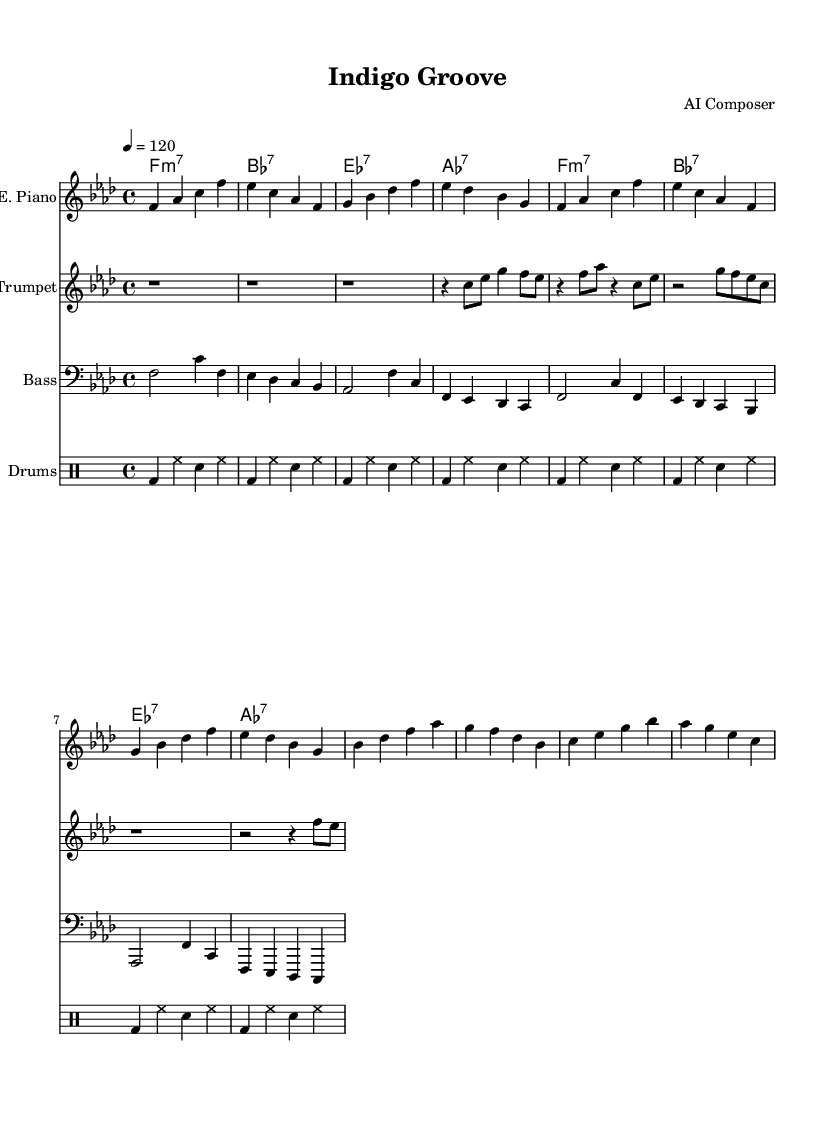What is the key signature of this music? The key signature in the sheet music is indicated by the F minor scale, which has four flats: B♭, E♭, A♭, and D♭. This can be seen in the key signature section found at the beginning of the sheet music.
Answer: F minor What is the time signature of this piece? The time signature is shown at the beginning of the score as 4/4, meaning there are four beats in a measure and the quarter note gets one beat. This information is typically located right next to the key signature in the sheet music.
Answer: 4/4 What is the tempo marking for this music? The tempo marking of the piece is indicated as 4 = 120. This means that the quarter note (4) should be played at a speed of 120 beats per minute, which is located at the beginning of the score.
Answer: 120 How many measures are included in the electric piano part? By counting the number of bar lines (vertical lines) in the electric piano part, we find that there are 8 measures total. Each bar line denotes the end of a measure, and careful counting reveals the total.
Answer: 8 What is the dominant chord used in the chorus? The dominant chord (the fifth chord) of the key of F minor is C major or C7, which is represented in the chord names section of the sheet music. Chord names typically indicate harmonic progressions and help identify key chords.
Answer: C7 How many different instruments are featured in this piece? From the score layout, we can observe that there are four different staves for instruments: Electric Piano, Trumpet, Bass, and Drums. Each staff corresponds to a separate instrument part being played.
Answer: Four What rhythmic element is prominently featured in the drum part? The drum part prominently features a bass drum (bd) on the first beat of each measure, followed by hi-hat (hh) and snare (sn) patterns. The pattern of bass, hi-hat, and snare creates a distinct rhythmic groove, which is identified in the drummode notation.
Answer: Bass drum 